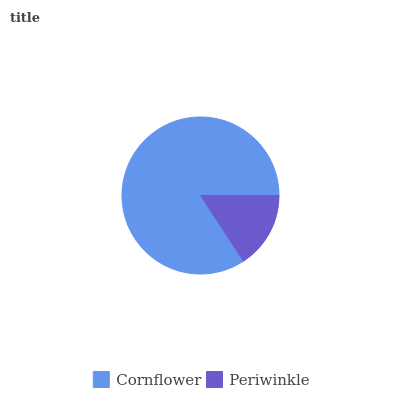Is Periwinkle the minimum?
Answer yes or no. Yes. Is Cornflower the maximum?
Answer yes or no. Yes. Is Periwinkle the maximum?
Answer yes or no. No. Is Cornflower greater than Periwinkle?
Answer yes or no. Yes. Is Periwinkle less than Cornflower?
Answer yes or no. Yes. Is Periwinkle greater than Cornflower?
Answer yes or no. No. Is Cornflower less than Periwinkle?
Answer yes or no. No. Is Cornflower the high median?
Answer yes or no. Yes. Is Periwinkle the low median?
Answer yes or no. Yes. Is Periwinkle the high median?
Answer yes or no. No. Is Cornflower the low median?
Answer yes or no. No. 